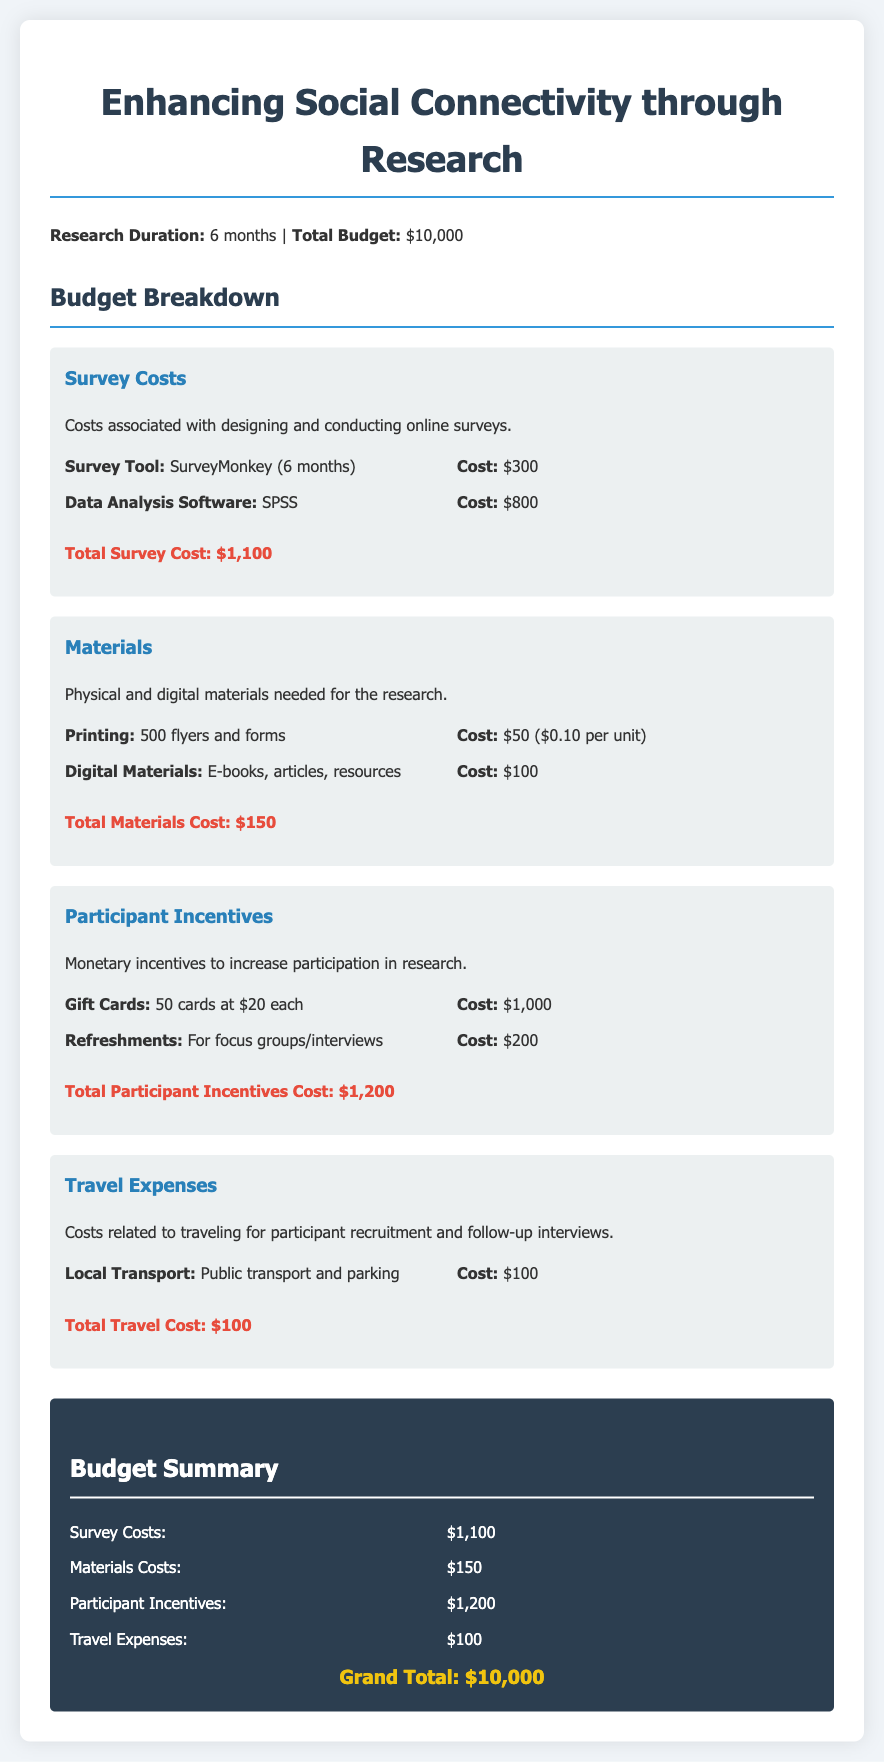what is the total budget for the research project? The total budget is stated at the beginning of the document as $10,000.
Answer: $10,000 how much does the survey tool cost? The cost of SurveyMonkey for 6 months is specified in the survey costs section as $300.
Answer: $300 what are the total participant incentives? The total cost for participant incentives is detailed in the document as $1,200.
Answer: $1,200 how many gift cards are budgeted for participant incentives? The document mentions that 50 gift cards are allocated at $20 each for participant incentives.
Answer: 50 what is the cost associated with the data analysis software? The document states that SPSS has a cost of $800 included in the survey costs.
Answer: $800 what is the total cost for materials? The document summarizes the total cost for materials as $150.
Answer: $150 how much is allocated for local transport in travel expenses? The cost for local transport is explicitly stated as $100 in the travel expenses section.
Answer: $100 how many flyers are planned for printing? According to the materials section, 500 flyers are planned for printing.
Answer: 500 what is the duration of the research project? The document specifies that the duration of the research project is 6 months.
Answer: 6 months 